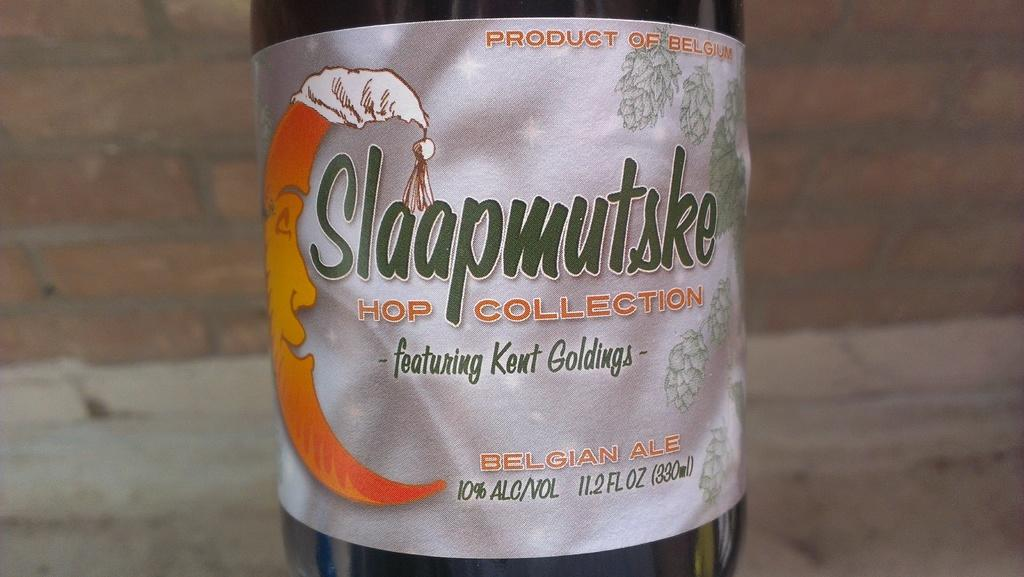<image>
Create a compact narrative representing the image presented. According to its label, Slaapmutske Hop Collection is a product of Belgium. 